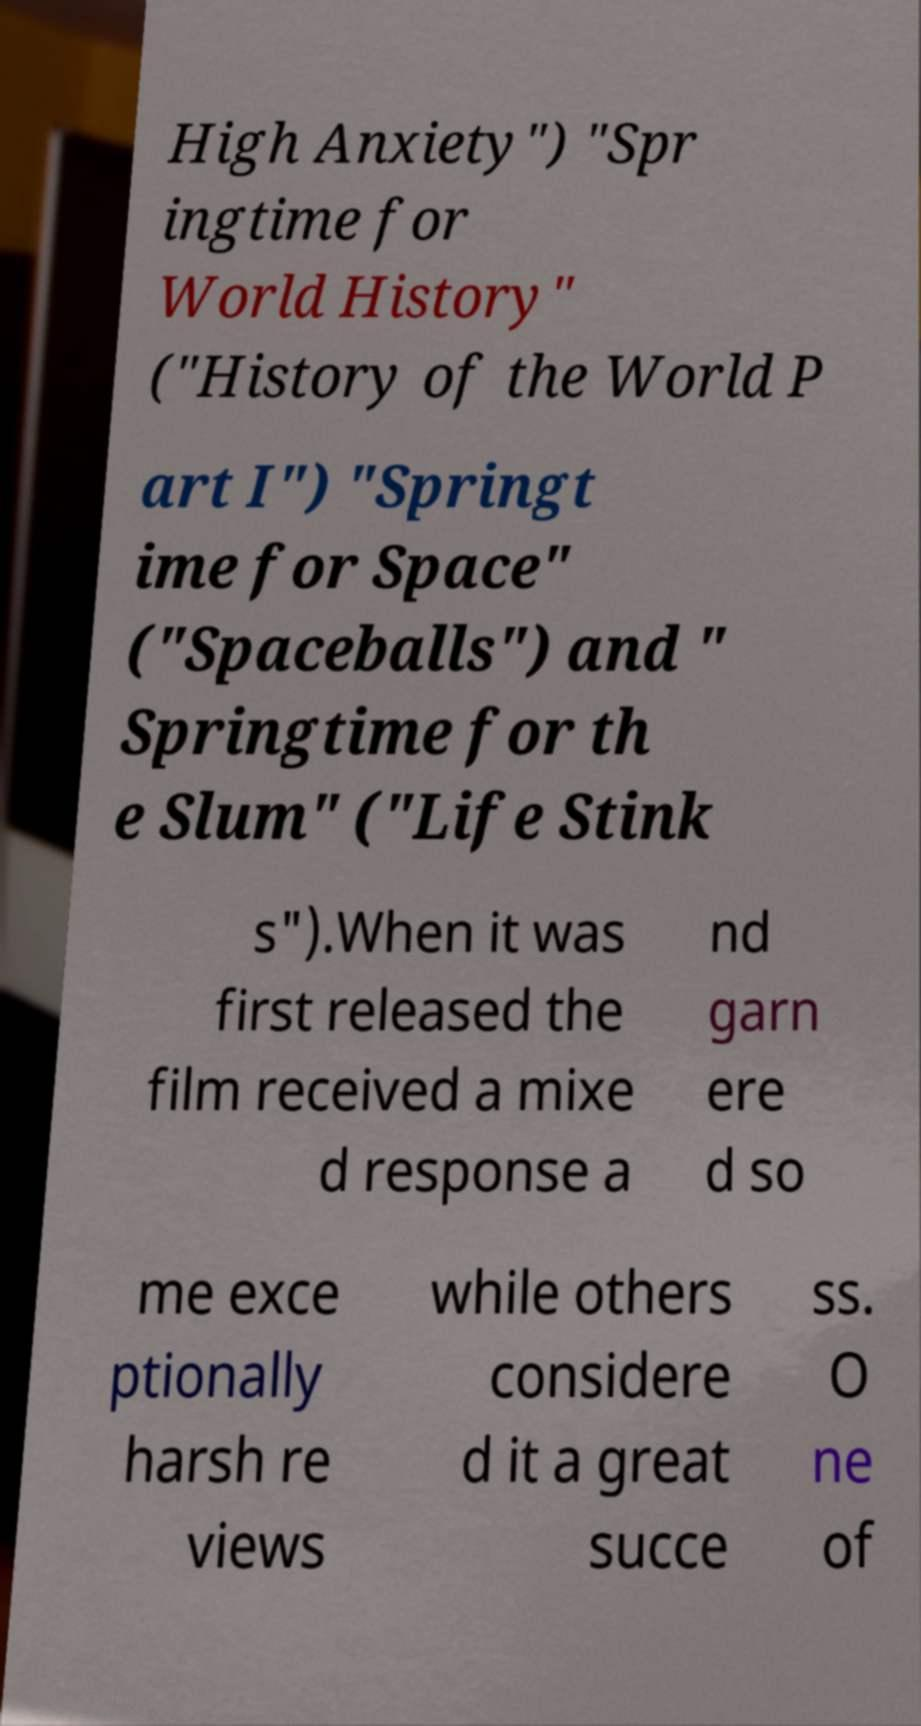Could you assist in decoding the text presented in this image and type it out clearly? High Anxiety") "Spr ingtime for World History" ("History of the World P art I") "Springt ime for Space" ("Spaceballs") and " Springtime for th e Slum" ("Life Stink s").When it was first released the film received a mixe d response a nd garn ere d so me exce ptionally harsh re views while others considere d it a great succe ss. O ne of 